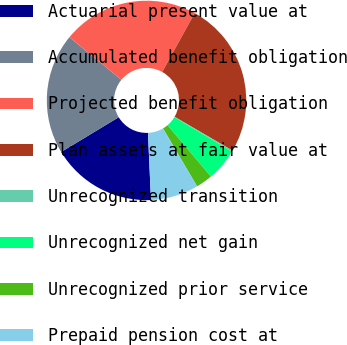Convert chart. <chart><loc_0><loc_0><loc_500><loc_500><pie_chart><fcel>Actuarial present value at<fcel>Accumulated benefit obligation<fcel>Projected benefit obligation<fcel>Plan assets at fair value at<fcel>Unrecognized transition<fcel>Unrecognized net gain<fcel>Unrecognized prior service<fcel>Prepaid pension cost at<nl><fcel>17.06%<fcel>19.58%<fcel>22.1%<fcel>25.39%<fcel>0.19%<fcel>5.23%<fcel>2.71%<fcel>7.75%<nl></chart> 